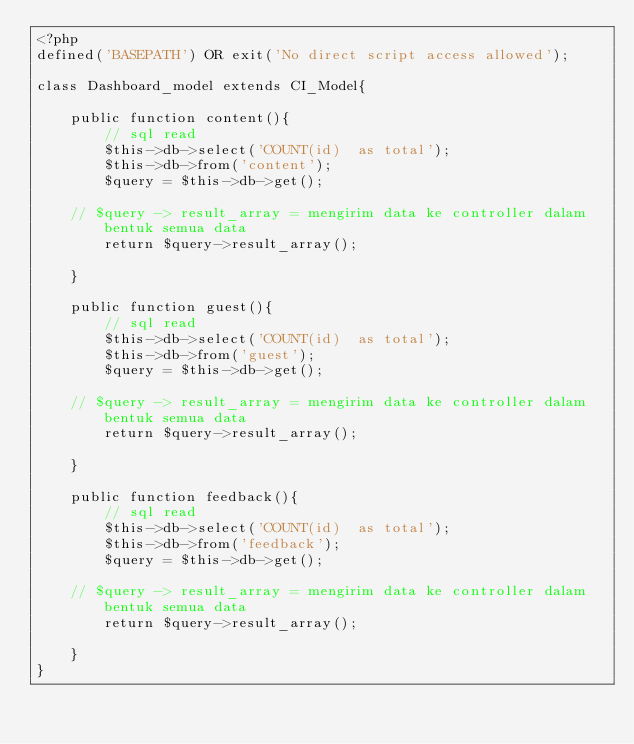<code> <loc_0><loc_0><loc_500><loc_500><_PHP_><?php
defined('BASEPATH') OR exit('No direct script access allowed');

class Dashboard_model extends CI_Model{

    public function content(){
        // sql read
        $this->db->select('COUNT(id)  as total');
        $this->db->from('content');
        $query = $this->db->get();

		// $query -> result_array = mengirim data ke controller dalam bentuk semua data
        return $query->result_array();

    }

    public function guest(){
        // sql read
        $this->db->select('COUNT(id)  as total');
        $this->db->from('guest');
        $query = $this->db->get();

		// $query -> result_array = mengirim data ke controller dalam bentuk semua data
        return $query->result_array();

    }

    public function feedback(){
        // sql read
        $this->db->select('COUNT(id)  as total');
        $this->db->from('feedback');
        $query = $this->db->get();

		// $query -> result_array = mengirim data ke controller dalam bentuk semua data
        return $query->result_array();

    }
}</code> 